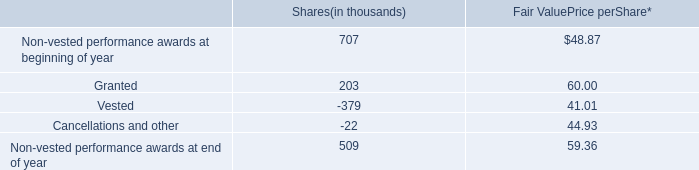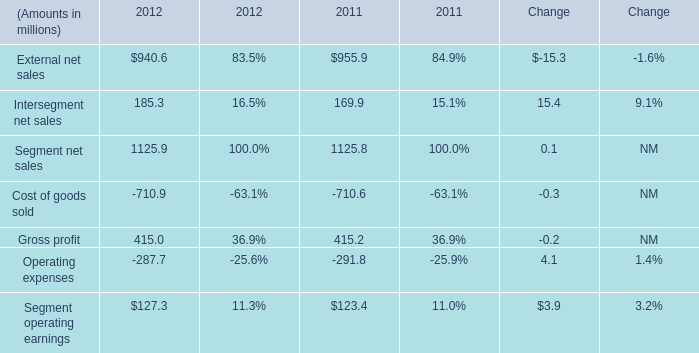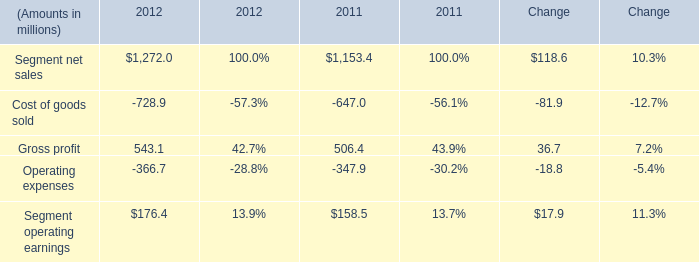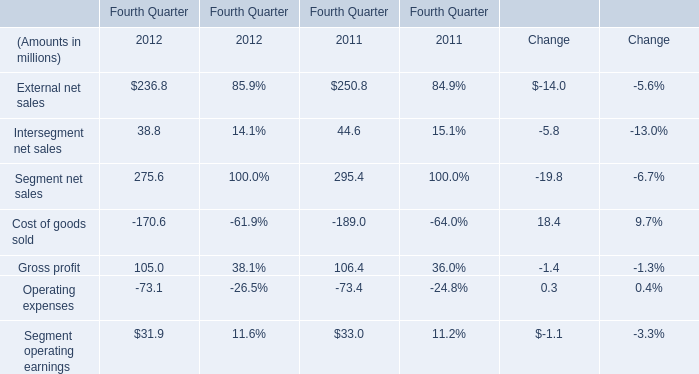What was the average value of Segment net salesCost of goods soldGross profit in 2012 ? (in million) 
Computations: (((275.6 - 170.6) + 105) / 3)
Answer: 70.0. 